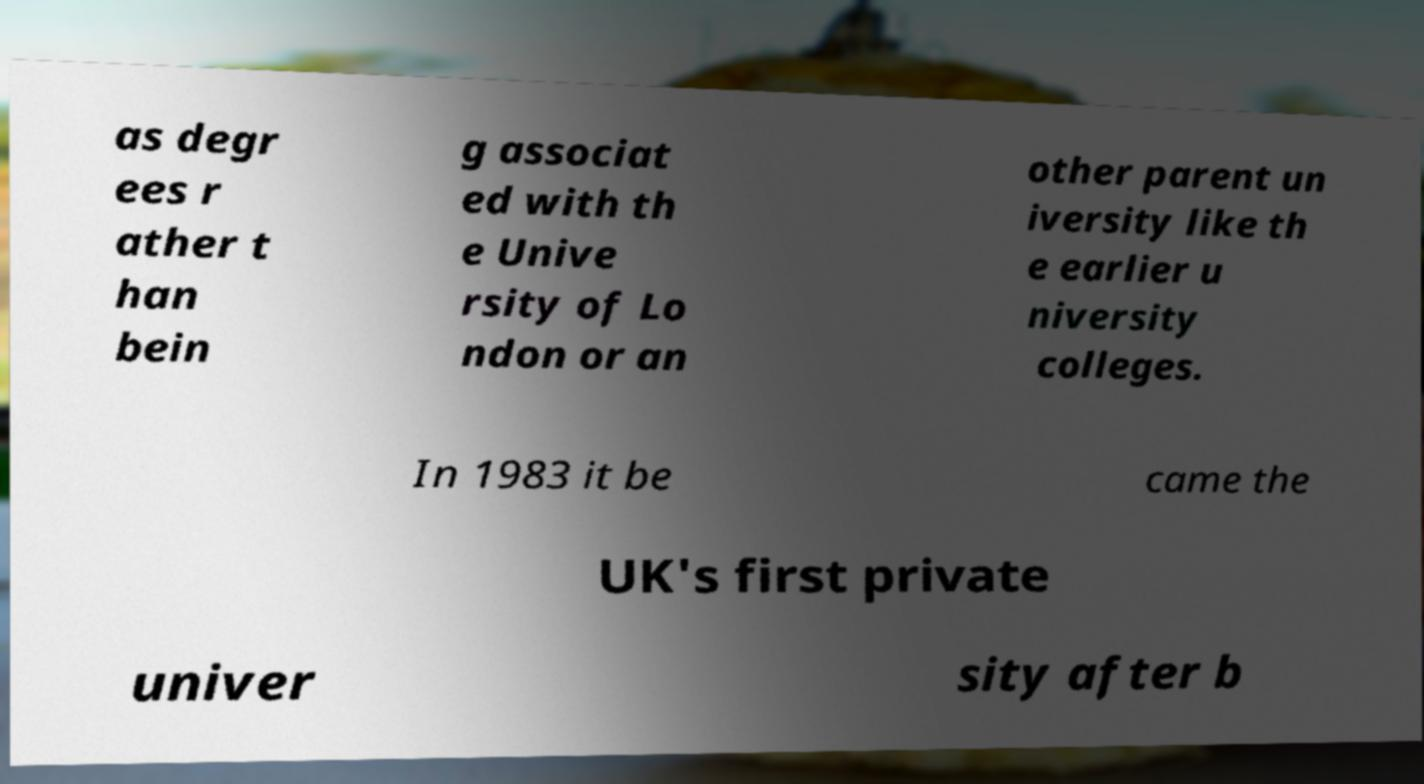Could you extract and type out the text from this image? as degr ees r ather t han bein g associat ed with th e Unive rsity of Lo ndon or an other parent un iversity like th e earlier u niversity colleges. In 1983 it be came the UK's first private univer sity after b 